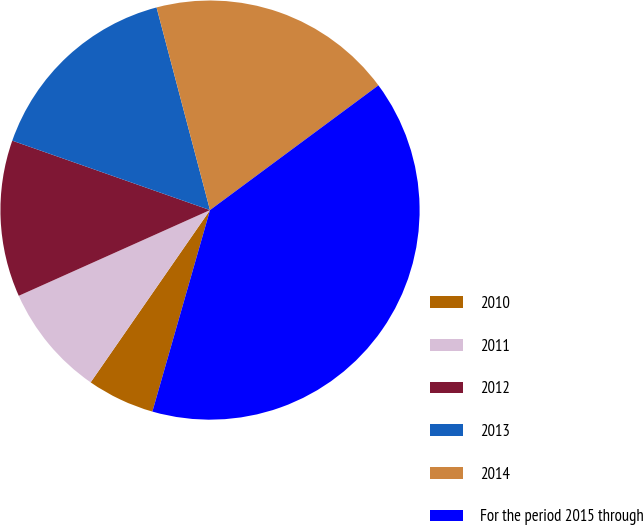Convert chart to OTSL. <chart><loc_0><loc_0><loc_500><loc_500><pie_chart><fcel>2010<fcel>2011<fcel>2012<fcel>2013<fcel>2014<fcel>For the period 2015 through<nl><fcel>5.21%<fcel>8.65%<fcel>12.08%<fcel>15.52%<fcel>18.96%<fcel>39.58%<nl></chart> 